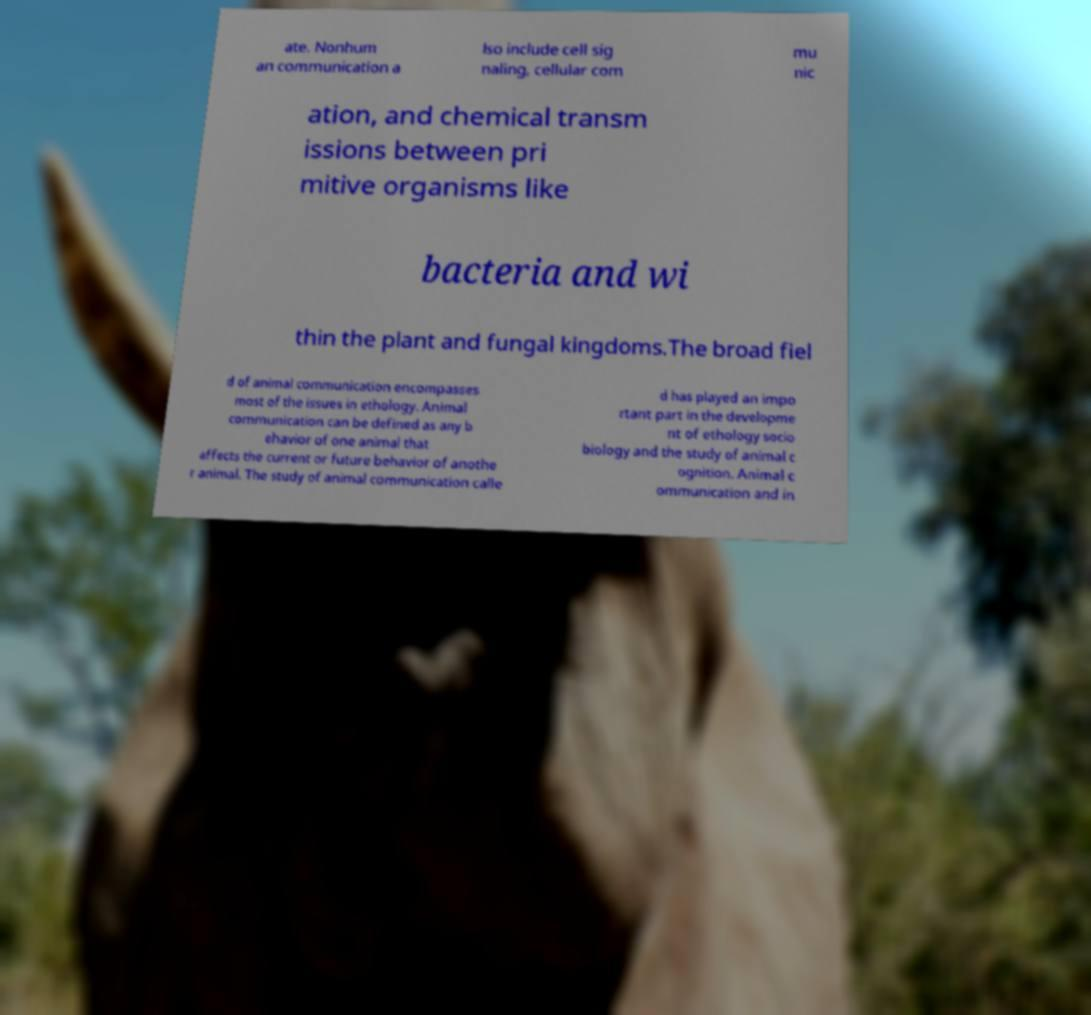For documentation purposes, I need the text within this image transcribed. Could you provide that? ate. Nonhum an communication a lso include cell sig naling, cellular com mu nic ation, and chemical transm issions between pri mitive organisms like bacteria and wi thin the plant and fungal kingdoms.The broad fiel d of animal communication encompasses most of the issues in ethology. Animal communication can be defined as any b ehavior of one animal that affects the current or future behavior of anothe r animal. The study of animal communication calle d has played an impo rtant part in the developme nt of ethology socio biology and the study of animal c ognition. Animal c ommunication and in 